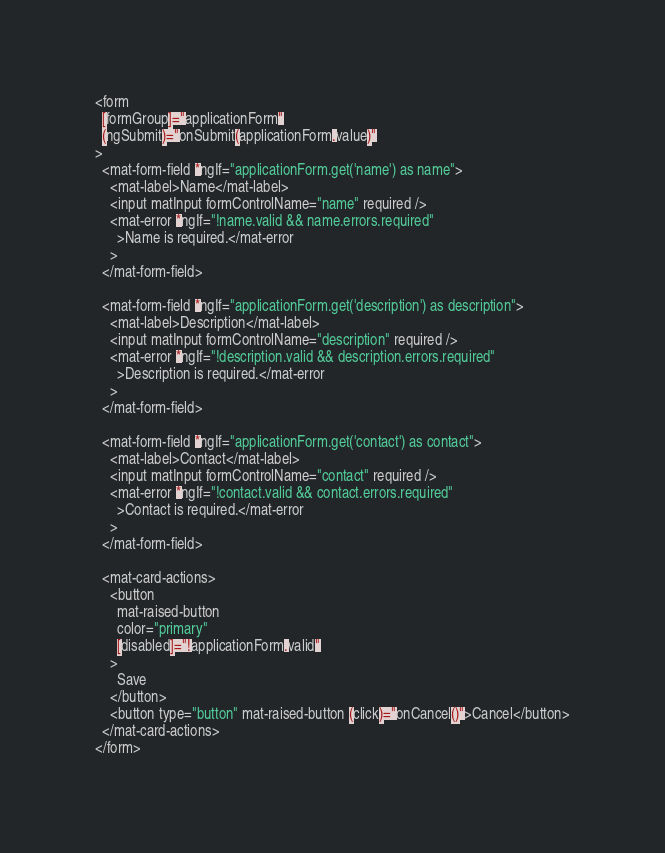Convert code to text. <code><loc_0><loc_0><loc_500><loc_500><_HTML_><form
  [formGroup]="applicationForm"
  (ngSubmit)="onSubmit(applicationForm.value)"
>
  <mat-form-field *ngIf="applicationForm.get('name') as name">
    <mat-label>Name</mat-label>
    <input matInput formControlName="name" required />
    <mat-error *ngIf="!name.valid && name.errors.required"
      >Name is required.</mat-error
    >
  </mat-form-field>

  <mat-form-field *ngIf="applicationForm.get('description') as description">
    <mat-label>Description</mat-label>
    <input matInput formControlName="description" required />
    <mat-error *ngIf="!description.valid && description.errors.required"
      >Description is required.</mat-error
    >
  </mat-form-field>

  <mat-form-field *ngIf="applicationForm.get('contact') as contact">
    <mat-label>Contact</mat-label>
    <input matInput formControlName="contact" required />
    <mat-error *ngIf="!contact.valid && contact.errors.required"
      >Contact is required.</mat-error
    >
  </mat-form-field>

  <mat-card-actions>
    <button
      mat-raised-button
      color="primary"
      [disabled]="!applicationForm.valid"
    >
      Save
    </button>
    <button type="button" mat-raised-button (click)="onCancel()">Cancel</button>
  </mat-card-actions>
</form>
</code> 